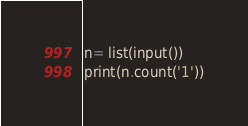Convert code to text. <code><loc_0><loc_0><loc_500><loc_500><_Python_>n= list(input())
print(n.count('1'))</code> 